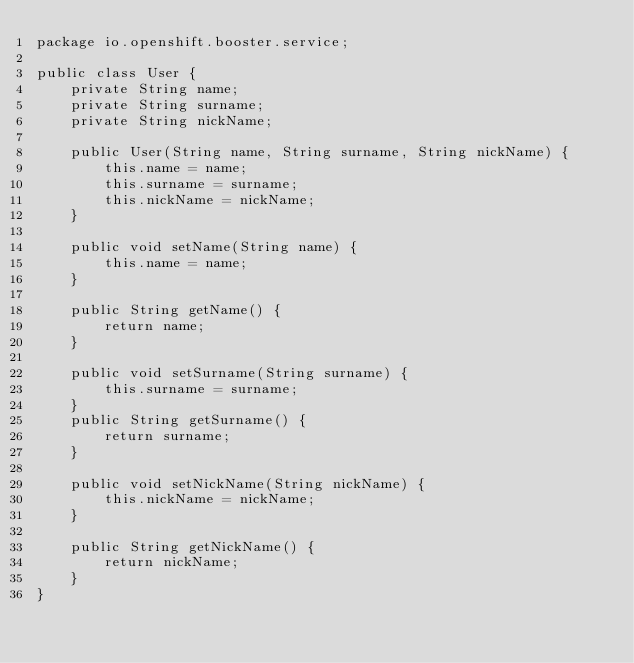<code> <loc_0><loc_0><loc_500><loc_500><_Java_>package io.openshift.booster.service;

public class User {
    private String name;
    private String surname;
    private String nickName;
    
    public User(String name, String surname, String nickName) {
        this.name = name;
        this.surname = surname;
        this.nickName = nickName;
    }
    
    public void setName(String name) {
        this.name = name;
    }
    
    public String getName() {
        return name;
    }
    
    public void setSurname(String surname) {
        this.surname = surname;
    }
    public String getSurname() {
        return surname;
    }
    
    public void setNickName(String nickName) {
        this.nickName = nickName;
    }
    
    public String getNickName() {
        return nickName;
    }
}
</code> 